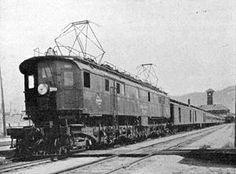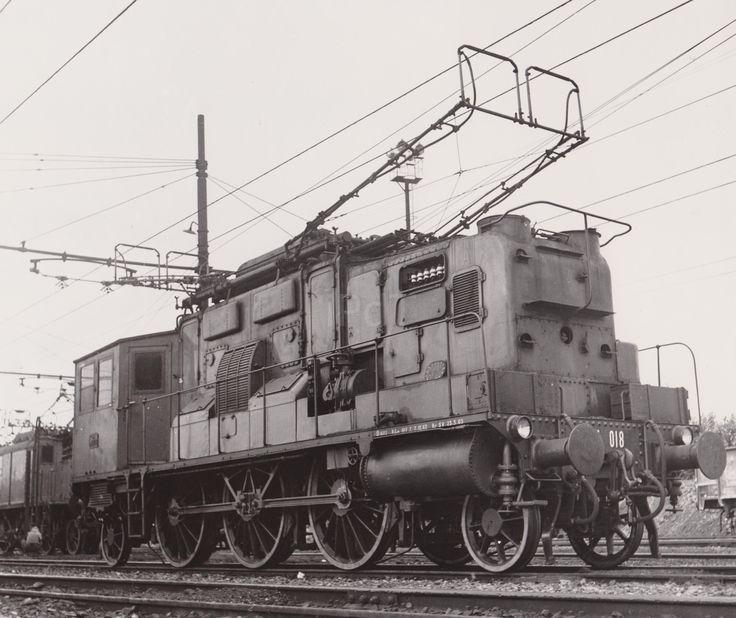The first image is the image on the left, the second image is the image on the right. Evaluate the accuracy of this statement regarding the images: "There are two trains facing opposite directions, in black and white.". Is it true? Answer yes or no. Yes. 